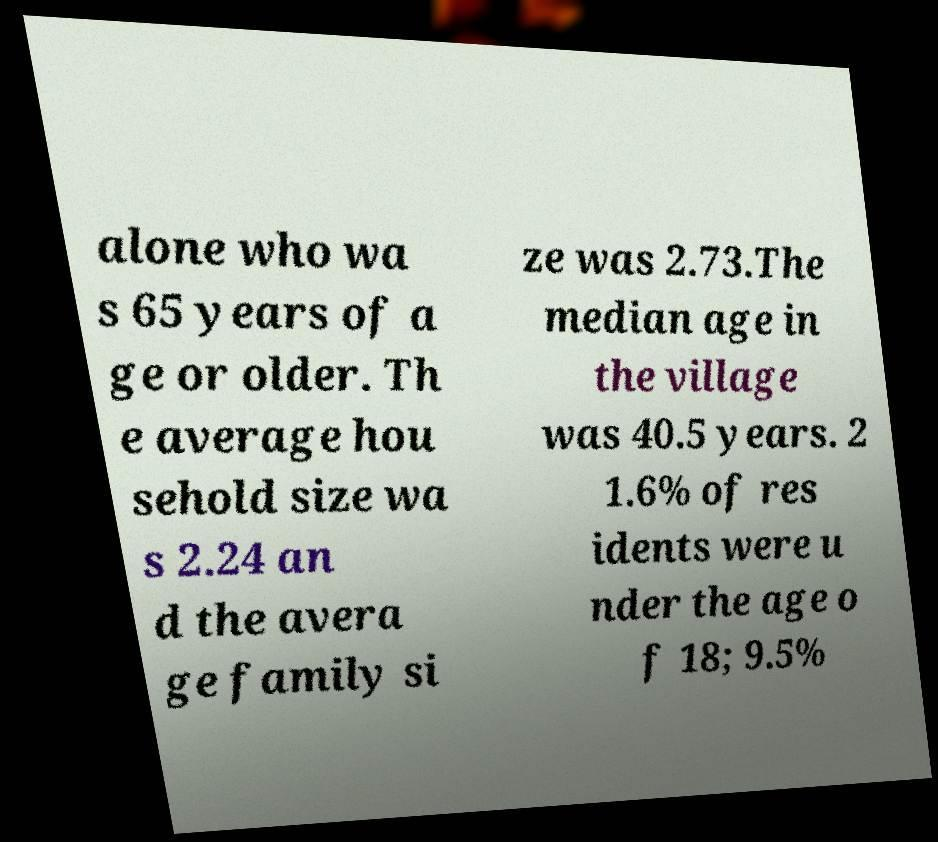Could you assist in decoding the text presented in this image and type it out clearly? alone who wa s 65 years of a ge or older. Th e average hou sehold size wa s 2.24 an d the avera ge family si ze was 2.73.The median age in the village was 40.5 years. 2 1.6% of res idents were u nder the age o f 18; 9.5% 